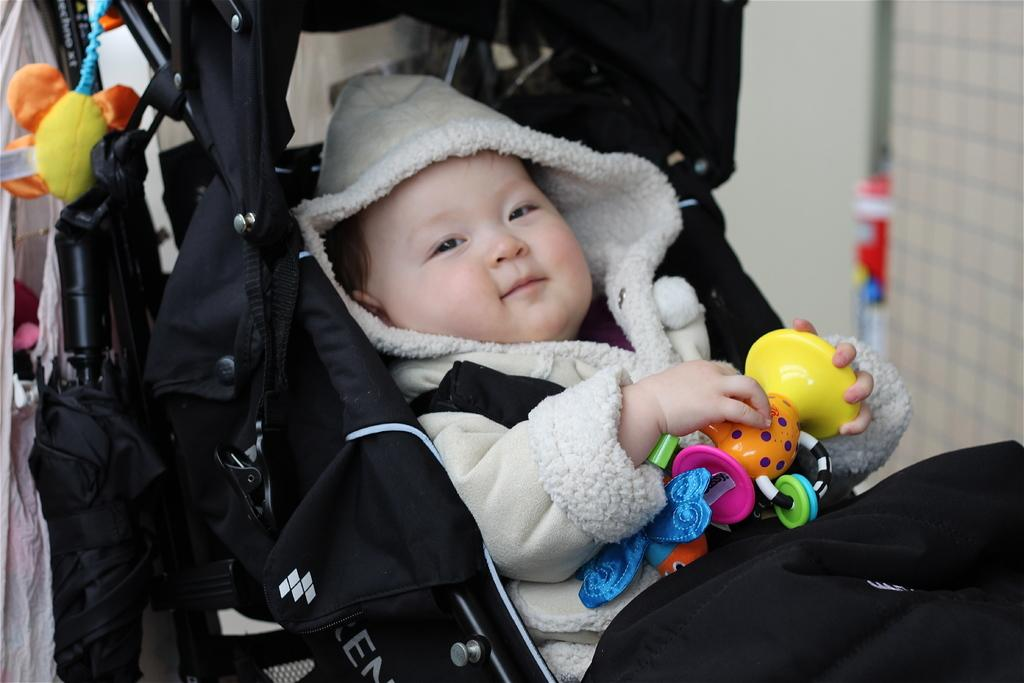What is the main subject of the image? There is a baby in the image. What is the baby holding in the image? The baby is holding a toy. Where is the baby located in the image? The baby is lying in a stroller. Can you describe the background of the image? There are objects in the background of the image. What type of oil can be seen dripping from the toy in the image? There is no oil present in the image, and the toy is not shown to be dripping anything. 